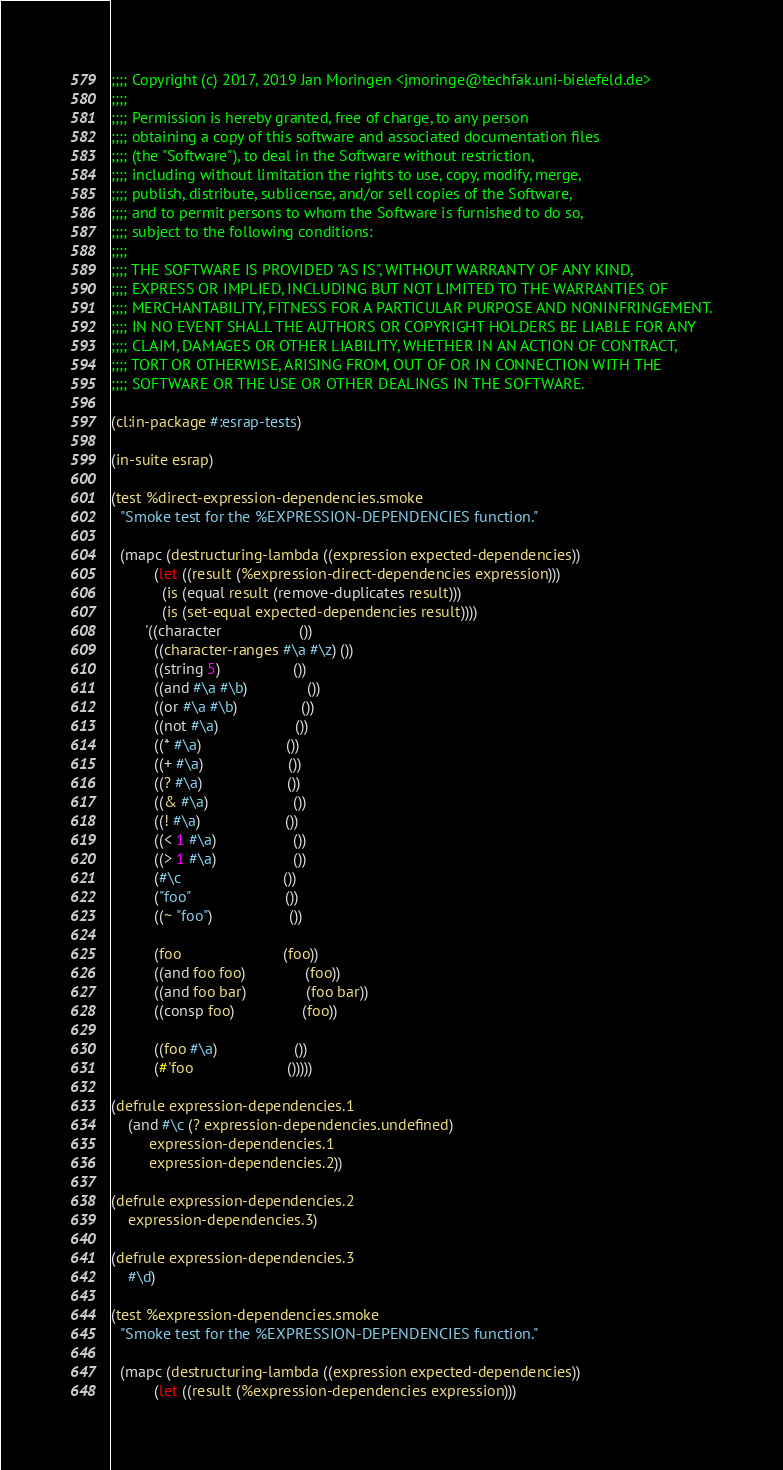<code> <loc_0><loc_0><loc_500><loc_500><_Lisp_>;;;; Copyright (c) 2017, 2019 Jan Moringen <jmoringe@techfak.uni-bielefeld.de>
;;;;
;;;; Permission is hereby granted, free of charge, to any person
;;;; obtaining a copy of this software and associated documentation files
;;;; (the "Software"), to deal in the Software without restriction,
;;;; including without limitation the rights to use, copy, modify, merge,
;;;; publish, distribute, sublicense, and/or sell copies of the Software,
;;;; and to permit persons to whom the Software is furnished to do so,
;;;; subject to the following conditions:
;;;;
;;;; THE SOFTWARE IS PROVIDED "AS IS", WITHOUT WARRANTY OF ANY KIND,
;;;; EXPRESS OR IMPLIED, INCLUDING BUT NOT LIMITED TO THE WARRANTIES OF
;;;; MERCHANTABILITY, FITNESS FOR A PARTICULAR PURPOSE AND NONINFRINGEMENT.
;;;; IN NO EVENT SHALL THE AUTHORS OR COPYRIGHT HOLDERS BE LIABLE FOR ANY
;;;; CLAIM, DAMAGES OR OTHER LIABILITY, WHETHER IN AN ACTION OF CONTRACT,
;;;; TORT OR OTHERWISE, ARISING FROM, OUT OF OR IN CONNECTION WITH THE
;;;; SOFTWARE OR THE USE OR OTHER DEALINGS IN THE SOFTWARE.

(cl:in-package #:esrap-tests)

(in-suite esrap)

(test %direct-expression-dependencies.smoke
  "Smoke test for the %EXPRESSION-DEPENDENCIES function."

  (mapc (destructuring-lambda ((expression expected-dependencies))
          (let ((result (%expression-direct-dependencies expression)))
            (is (equal result (remove-duplicates result)))
            (is (set-equal expected-dependencies result))))
        '((character                  ())
          ((character-ranges #\a #\z) ())
          ((string 5)                 ())
          ((and #\a #\b)              ())
          ((or #\a #\b)               ())
          ((not #\a)                  ())
          ((* #\a)                    ())
          ((+ #\a)                    ())
          ((? #\a)                    ())
          ((& #\a)                    ())
          ((! #\a)                    ())
          ((< 1 #\a)                  ())
          ((> 1 #\a)                  ())
          (#\c                        ())
          ("foo"                      ())
          ((~ "foo")                  ())

          (foo                        (foo))
          ((and foo foo)              (foo))
          ((and foo bar)              (foo bar))
          ((consp foo)                (foo))

          ((foo #\a)                  ())
          (#'foo                      ()))))

(defrule expression-dependencies.1
    (and #\c (? expression-dependencies.undefined)
         expression-dependencies.1
         expression-dependencies.2))

(defrule expression-dependencies.2
    expression-dependencies.3)

(defrule expression-dependencies.3
    #\d)

(test %expression-dependencies.smoke
  "Smoke test for the %EXPRESSION-DEPENDENCIES function."

  (mapc (destructuring-lambda ((expression expected-dependencies))
          (let ((result (%expression-dependencies expression)))</code> 